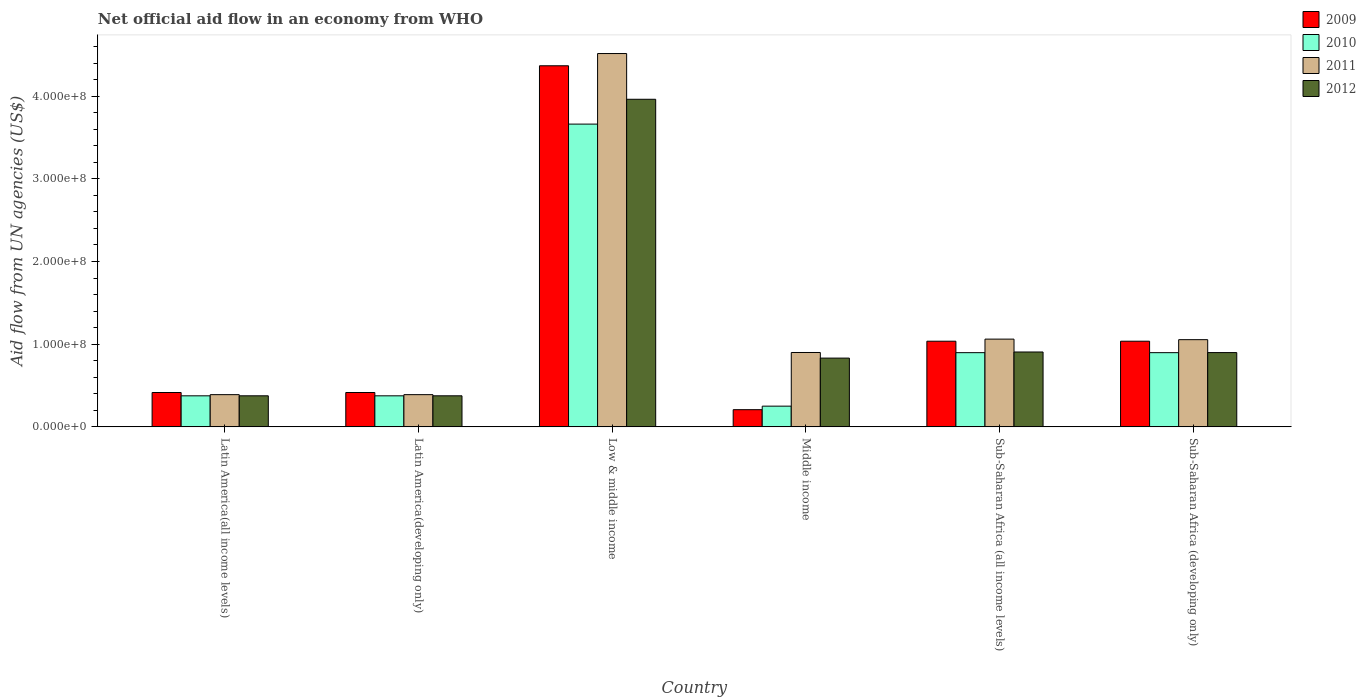How many different coloured bars are there?
Give a very brief answer. 4. How many groups of bars are there?
Ensure brevity in your answer.  6. How many bars are there on the 5th tick from the right?
Ensure brevity in your answer.  4. What is the label of the 2nd group of bars from the left?
Your answer should be compact. Latin America(developing only). What is the net official aid flow in 2009 in Middle income?
Your answer should be very brief. 2.08e+07. Across all countries, what is the maximum net official aid flow in 2009?
Your answer should be very brief. 4.37e+08. Across all countries, what is the minimum net official aid flow in 2009?
Your answer should be very brief. 2.08e+07. In which country was the net official aid flow in 2011 maximum?
Offer a terse response. Low & middle income. In which country was the net official aid flow in 2009 minimum?
Ensure brevity in your answer.  Middle income. What is the total net official aid flow in 2011 in the graph?
Keep it short and to the point. 8.31e+08. What is the difference between the net official aid flow in 2011 in Latin America(developing only) and that in Sub-Saharan Africa (developing only)?
Ensure brevity in your answer.  -6.65e+07. What is the difference between the net official aid flow in 2011 in Middle income and the net official aid flow in 2009 in Sub-Saharan Africa (developing only)?
Make the answer very short. -1.36e+07. What is the average net official aid flow in 2011 per country?
Provide a short and direct response. 1.39e+08. What is the difference between the net official aid flow of/in 2011 and net official aid flow of/in 2010 in Sub-Saharan Africa (developing only)?
Ensure brevity in your answer.  1.57e+07. What is the ratio of the net official aid flow in 2011 in Latin America(all income levels) to that in Middle income?
Offer a terse response. 0.43. Is the difference between the net official aid flow in 2011 in Low & middle income and Middle income greater than the difference between the net official aid flow in 2010 in Low & middle income and Middle income?
Your answer should be compact. Yes. What is the difference between the highest and the second highest net official aid flow in 2011?
Give a very brief answer. 3.46e+08. What is the difference between the highest and the lowest net official aid flow in 2010?
Provide a succinct answer. 3.41e+08. In how many countries, is the net official aid flow in 2010 greater than the average net official aid flow in 2010 taken over all countries?
Ensure brevity in your answer.  1. Is the sum of the net official aid flow in 2009 in Latin America(developing only) and Sub-Saharan Africa (all income levels) greater than the maximum net official aid flow in 2012 across all countries?
Give a very brief answer. No. Is it the case that in every country, the sum of the net official aid flow in 2009 and net official aid flow in 2012 is greater than the sum of net official aid flow in 2011 and net official aid flow in 2010?
Provide a short and direct response. No. What does the 1st bar from the right in Sub-Saharan Africa (developing only) represents?
Keep it short and to the point. 2012. Is it the case that in every country, the sum of the net official aid flow in 2009 and net official aid flow in 2010 is greater than the net official aid flow in 2012?
Offer a very short reply. No. How many bars are there?
Your answer should be compact. 24. What is the difference between two consecutive major ticks on the Y-axis?
Offer a very short reply. 1.00e+08. Does the graph contain grids?
Keep it short and to the point. No. What is the title of the graph?
Give a very brief answer. Net official aid flow in an economy from WHO. What is the label or title of the Y-axis?
Your answer should be compact. Aid flow from UN agencies (US$). What is the Aid flow from UN agencies (US$) of 2009 in Latin America(all income levels)?
Your answer should be very brief. 4.16e+07. What is the Aid flow from UN agencies (US$) of 2010 in Latin America(all income levels)?
Your answer should be very brief. 3.76e+07. What is the Aid flow from UN agencies (US$) in 2011 in Latin America(all income levels)?
Your answer should be compact. 3.90e+07. What is the Aid flow from UN agencies (US$) of 2012 in Latin America(all income levels)?
Provide a short and direct response. 3.76e+07. What is the Aid flow from UN agencies (US$) of 2009 in Latin America(developing only)?
Offer a terse response. 4.16e+07. What is the Aid flow from UN agencies (US$) in 2010 in Latin America(developing only)?
Provide a short and direct response. 3.76e+07. What is the Aid flow from UN agencies (US$) of 2011 in Latin America(developing only)?
Provide a succinct answer. 3.90e+07. What is the Aid flow from UN agencies (US$) of 2012 in Latin America(developing only)?
Your response must be concise. 3.76e+07. What is the Aid flow from UN agencies (US$) in 2009 in Low & middle income?
Your answer should be very brief. 4.37e+08. What is the Aid flow from UN agencies (US$) of 2010 in Low & middle income?
Your answer should be compact. 3.66e+08. What is the Aid flow from UN agencies (US$) of 2011 in Low & middle income?
Provide a short and direct response. 4.52e+08. What is the Aid flow from UN agencies (US$) of 2012 in Low & middle income?
Ensure brevity in your answer.  3.96e+08. What is the Aid flow from UN agencies (US$) in 2009 in Middle income?
Keep it short and to the point. 2.08e+07. What is the Aid flow from UN agencies (US$) of 2010 in Middle income?
Your response must be concise. 2.51e+07. What is the Aid flow from UN agencies (US$) in 2011 in Middle income?
Provide a short and direct response. 9.00e+07. What is the Aid flow from UN agencies (US$) of 2012 in Middle income?
Provide a succinct answer. 8.32e+07. What is the Aid flow from UN agencies (US$) of 2009 in Sub-Saharan Africa (all income levels)?
Keep it short and to the point. 1.04e+08. What is the Aid flow from UN agencies (US$) of 2010 in Sub-Saharan Africa (all income levels)?
Offer a very short reply. 8.98e+07. What is the Aid flow from UN agencies (US$) of 2011 in Sub-Saharan Africa (all income levels)?
Offer a very short reply. 1.06e+08. What is the Aid flow from UN agencies (US$) of 2012 in Sub-Saharan Africa (all income levels)?
Keep it short and to the point. 9.06e+07. What is the Aid flow from UN agencies (US$) of 2009 in Sub-Saharan Africa (developing only)?
Provide a short and direct response. 1.04e+08. What is the Aid flow from UN agencies (US$) of 2010 in Sub-Saharan Africa (developing only)?
Your answer should be very brief. 8.98e+07. What is the Aid flow from UN agencies (US$) in 2011 in Sub-Saharan Africa (developing only)?
Your answer should be very brief. 1.05e+08. What is the Aid flow from UN agencies (US$) in 2012 in Sub-Saharan Africa (developing only)?
Your answer should be compact. 8.98e+07. Across all countries, what is the maximum Aid flow from UN agencies (US$) in 2009?
Provide a succinct answer. 4.37e+08. Across all countries, what is the maximum Aid flow from UN agencies (US$) in 2010?
Offer a very short reply. 3.66e+08. Across all countries, what is the maximum Aid flow from UN agencies (US$) of 2011?
Keep it short and to the point. 4.52e+08. Across all countries, what is the maximum Aid flow from UN agencies (US$) in 2012?
Your answer should be very brief. 3.96e+08. Across all countries, what is the minimum Aid flow from UN agencies (US$) of 2009?
Give a very brief answer. 2.08e+07. Across all countries, what is the minimum Aid flow from UN agencies (US$) in 2010?
Give a very brief answer. 2.51e+07. Across all countries, what is the minimum Aid flow from UN agencies (US$) of 2011?
Make the answer very short. 3.90e+07. Across all countries, what is the minimum Aid flow from UN agencies (US$) in 2012?
Offer a very short reply. 3.76e+07. What is the total Aid flow from UN agencies (US$) in 2009 in the graph?
Give a very brief answer. 7.48e+08. What is the total Aid flow from UN agencies (US$) of 2010 in the graph?
Provide a short and direct response. 6.46e+08. What is the total Aid flow from UN agencies (US$) of 2011 in the graph?
Offer a very short reply. 8.31e+08. What is the total Aid flow from UN agencies (US$) of 2012 in the graph?
Provide a short and direct response. 7.35e+08. What is the difference between the Aid flow from UN agencies (US$) of 2009 in Latin America(all income levels) and that in Latin America(developing only)?
Make the answer very short. 0. What is the difference between the Aid flow from UN agencies (US$) in 2012 in Latin America(all income levels) and that in Latin America(developing only)?
Keep it short and to the point. 0. What is the difference between the Aid flow from UN agencies (US$) of 2009 in Latin America(all income levels) and that in Low & middle income?
Provide a short and direct response. -3.95e+08. What is the difference between the Aid flow from UN agencies (US$) in 2010 in Latin America(all income levels) and that in Low & middle income?
Make the answer very short. -3.29e+08. What is the difference between the Aid flow from UN agencies (US$) of 2011 in Latin America(all income levels) and that in Low & middle income?
Offer a terse response. -4.13e+08. What is the difference between the Aid flow from UN agencies (US$) in 2012 in Latin America(all income levels) and that in Low & middle income?
Your answer should be compact. -3.59e+08. What is the difference between the Aid flow from UN agencies (US$) in 2009 in Latin America(all income levels) and that in Middle income?
Provide a short and direct response. 2.08e+07. What is the difference between the Aid flow from UN agencies (US$) of 2010 in Latin America(all income levels) and that in Middle income?
Your answer should be very brief. 1.25e+07. What is the difference between the Aid flow from UN agencies (US$) of 2011 in Latin America(all income levels) and that in Middle income?
Provide a short and direct response. -5.10e+07. What is the difference between the Aid flow from UN agencies (US$) in 2012 in Latin America(all income levels) and that in Middle income?
Your response must be concise. -4.56e+07. What is the difference between the Aid flow from UN agencies (US$) of 2009 in Latin America(all income levels) and that in Sub-Saharan Africa (all income levels)?
Provide a succinct answer. -6.20e+07. What is the difference between the Aid flow from UN agencies (US$) in 2010 in Latin America(all income levels) and that in Sub-Saharan Africa (all income levels)?
Provide a succinct answer. -5.22e+07. What is the difference between the Aid flow from UN agencies (US$) of 2011 in Latin America(all income levels) and that in Sub-Saharan Africa (all income levels)?
Provide a succinct answer. -6.72e+07. What is the difference between the Aid flow from UN agencies (US$) of 2012 in Latin America(all income levels) and that in Sub-Saharan Africa (all income levels)?
Keep it short and to the point. -5.30e+07. What is the difference between the Aid flow from UN agencies (US$) of 2009 in Latin America(all income levels) and that in Sub-Saharan Africa (developing only)?
Ensure brevity in your answer.  -6.20e+07. What is the difference between the Aid flow from UN agencies (US$) of 2010 in Latin America(all income levels) and that in Sub-Saharan Africa (developing only)?
Provide a succinct answer. -5.22e+07. What is the difference between the Aid flow from UN agencies (US$) of 2011 in Latin America(all income levels) and that in Sub-Saharan Africa (developing only)?
Give a very brief answer. -6.65e+07. What is the difference between the Aid flow from UN agencies (US$) of 2012 in Latin America(all income levels) and that in Sub-Saharan Africa (developing only)?
Offer a terse response. -5.23e+07. What is the difference between the Aid flow from UN agencies (US$) in 2009 in Latin America(developing only) and that in Low & middle income?
Provide a succinct answer. -3.95e+08. What is the difference between the Aid flow from UN agencies (US$) of 2010 in Latin America(developing only) and that in Low & middle income?
Offer a very short reply. -3.29e+08. What is the difference between the Aid flow from UN agencies (US$) in 2011 in Latin America(developing only) and that in Low & middle income?
Make the answer very short. -4.13e+08. What is the difference between the Aid flow from UN agencies (US$) in 2012 in Latin America(developing only) and that in Low & middle income?
Your answer should be compact. -3.59e+08. What is the difference between the Aid flow from UN agencies (US$) in 2009 in Latin America(developing only) and that in Middle income?
Offer a terse response. 2.08e+07. What is the difference between the Aid flow from UN agencies (US$) of 2010 in Latin America(developing only) and that in Middle income?
Your answer should be compact. 1.25e+07. What is the difference between the Aid flow from UN agencies (US$) in 2011 in Latin America(developing only) and that in Middle income?
Offer a very short reply. -5.10e+07. What is the difference between the Aid flow from UN agencies (US$) in 2012 in Latin America(developing only) and that in Middle income?
Make the answer very short. -4.56e+07. What is the difference between the Aid flow from UN agencies (US$) of 2009 in Latin America(developing only) and that in Sub-Saharan Africa (all income levels)?
Make the answer very short. -6.20e+07. What is the difference between the Aid flow from UN agencies (US$) of 2010 in Latin America(developing only) and that in Sub-Saharan Africa (all income levels)?
Offer a terse response. -5.22e+07. What is the difference between the Aid flow from UN agencies (US$) in 2011 in Latin America(developing only) and that in Sub-Saharan Africa (all income levels)?
Make the answer very short. -6.72e+07. What is the difference between the Aid flow from UN agencies (US$) in 2012 in Latin America(developing only) and that in Sub-Saharan Africa (all income levels)?
Keep it short and to the point. -5.30e+07. What is the difference between the Aid flow from UN agencies (US$) of 2009 in Latin America(developing only) and that in Sub-Saharan Africa (developing only)?
Your answer should be compact. -6.20e+07. What is the difference between the Aid flow from UN agencies (US$) of 2010 in Latin America(developing only) and that in Sub-Saharan Africa (developing only)?
Give a very brief answer. -5.22e+07. What is the difference between the Aid flow from UN agencies (US$) of 2011 in Latin America(developing only) and that in Sub-Saharan Africa (developing only)?
Provide a short and direct response. -6.65e+07. What is the difference between the Aid flow from UN agencies (US$) of 2012 in Latin America(developing only) and that in Sub-Saharan Africa (developing only)?
Your answer should be very brief. -5.23e+07. What is the difference between the Aid flow from UN agencies (US$) of 2009 in Low & middle income and that in Middle income?
Provide a short and direct response. 4.16e+08. What is the difference between the Aid flow from UN agencies (US$) in 2010 in Low & middle income and that in Middle income?
Your answer should be very brief. 3.41e+08. What is the difference between the Aid flow from UN agencies (US$) of 2011 in Low & middle income and that in Middle income?
Offer a terse response. 3.62e+08. What is the difference between the Aid flow from UN agencies (US$) of 2012 in Low & middle income and that in Middle income?
Your answer should be very brief. 3.13e+08. What is the difference between the Aid flow from UN agencies (US$) in 2009 in Low & middle income and that in Sub-Saharan Africa (all income levels)?
Provide a succinct answer. 3.33e+08. What is the difference between the Aid flow from UN agencies (US$) of 2010 in Low & middle income and that in Sub-Saharan Africa (all income levels)?
Provide a succinct answer. 2.76e+08. What is the difference between the Aid flow from UN agencies (US$) of 2011 in Low & middle income and that in Sub-Saharan Africa (all income levels)?
Provide a succinct answer. 3.45e+08. What is the difference between the Aid flow from UN agencies (US$) of 2012 in Low & middle income and that in Sub-Saharan Africa (all income levels)?
Give a very brief answer. 3.06e+08. What is the difference between the Aid flow from UN agencies (US$) in 2009 in Low & middle income and that in Sub-Saharan Africa (developing only)?
Make the answer very short. 3.33e+08. What is the difference between the Aid flow from UN agencies (US$) in 2010 in Low & middle income and that in Sub-Saharan Africa (developing only)?
Your response must be concise. 2.76e+08. What is the difference between the Aid flow from UN agencies (US$) of 2011 in Low & middle income and that in Sub-Saharan Africa (developing only)?
Give a very brief answer. 3.46e+08. What is the difference between the Aid flow from UN agencies (US$) in 2012 in Low & middle income and that in Sub-Saharan Africa (developing only)?
Offer a terse response. 3.06e+08. What is the difference between the Aid flow from UN agencies (US$) in 2009 in Middle income and that in Sub-Saharan Africa (all income levels)?
Your answer should be compact. -8.28e+07. What is the difference between the Aid flow from UN agencies (US$) in 2010 in Middle income and that in Sub-Saharan Africa (all income levels)?
Make the answer very short. -6.47e+07. What is the difference between the Aid flow from UN agencies (US$) of 2011 in Middle income and that in Sub-Saharan Africa (all income levels)?
Ensure brevity in your answer.  -1.62e+07. What is the difference between the Aid flow from UN agencies (US$) of 2012 in Middle income and that in Sub-Saharan Africa (all income levels)?
Your response must be concise. -7.39e+06. What is the difference between the Aid flow from UN agencies (US$) of 2009 in Middle income and that in Sub-Saharan Africa (developing only)?
Provide a short and direct response. -8.28e+07. What is the difference between the Aid flow from UN agencies (US$) of 2010 in Middle income and that in Sub-Saharan Africa (developing only)?
Your response must be concise. -6.47e+07. What is the difference between the Aid flow from UN agencies (US$) in 2011 in Middle income and that in Sub-Saharan Africa (developing only)?
Offer a very short reply. -1.55e+07. What is the difference between the Aid flow from UN agencies (US$) in 2012 in Middle income and that in Sub-Saharan Africa (developing only)?
Offer a terse response. -6.67e+06. What is the difference between the Aid flow from UN agencies (US$) in 2009 in Sub-Saharan Africa (all income levels) and that in Sub-Saharan Africa (developing only)?
Your answer should be compact. 0. What is the difference between the Aid flow from UN agencies (US$) in 2010 in Sub-Saharan Africa (all income levels) and that in Sub-Saharan Africa (developing only)?
Offer a terse response. 0. What is the difference between the Aid flow from UN agencies (US$) of 2011 in Sub-Saharan Africa (all income levels) and that in Sub-Saharan Africa (developing only)?
Provide a short and direct response. 6.70e+05. What is the difference between the Aid flow from UN agencies (US$) of 2012 in Sub-Saharan Africa (all income levels) and that in Sub-Saharan Africa (developing only)?
Your response must be concise. 7.20e+05. What is the difference between the Aid flow from UN agencies (US$) in 2009 in Latin America(all income levels) and the Aid flow from UN agencies (US$) in 2010 in Latin America(developing only)?
Your answer should be compact. 4.01e+06. What is the difference between the Aid flow from UN agencies (US$) of 2009 in Latin America(all income levels) and the Aid flow from UN agencies (US$) of 2011 in Latin America(developing only)?
Give a very brief answer. 2.59e+06. What is the difference between the Aid flow from UN agencies (US$) in 2009 in Latin America(all income levels) and the Aid flow from UN agencies (US$) in 2012 in Latin America(developing only)?
Your answer should be very brief. 3.99e+06. What is the difference between the Aid flow from UN agencies (US$) of 2010 in Latin America(all income levels) and the Aid flow from UN agencies (US$) of 2011 in Latin America(developing only)?
Give a very brief answer. -1.42e+06. What is the difference between the Aid flow from UN agencies (US$) of 2010 in Latin America(all income levels) and the Aid flow from UN agencies (US$) of 2012 in Latin America(developing only)?
Give a very brief answer. -2.00e+04. What is the difference between the Aid flow from UN agencies (US$) in 2011 in Latin America(all income levels) and the Aid flow from UN agencies (US$) in 2012 in Latin America(developing only)?
Provide a succinct answer. 1.40e+06. What is the difference between the Aid flow from UN agencies (US$) of 2009 in Latin America(all income levels) and the Aid flow from UN agencies (US$) of 2010 in Low & middle income?
Offer a very short reply. -3.25e+08. What is the difference between the Aid flow from UN agencies (US$) of 2009 in Latin America(all income levels) and the Aid flow from UN agencies (US$) of 2011 in Low & middle income?
Your answer should be compact. -4.10e+08. What is the difference between the Aid flow from UN agencies (US$) of 2009 in Latin America(all income levels) and the Aid flow from UN agencies (US$) of 2012 in Low & middle income?
Your response must be concise. -3.55e+08. What is the difference between the Aid flow from UN agencies (US$) of 2010 in Latin America(all income levels) and the Aid flow from UN agencies (US$) of 2011 in Low & middle income?
Provide a short and direct response. -4.14e+08. What is the difference between the Aid flow from UN agencies (US$) in 2010 in Latin America(all income levels) and the Aid flow from UN agencies (US$) in 2012 in Low & middle income?
Your answer should be very brief. -3.59e+08. What is the difference between the Aid flow from UN agencies (US$) in 2011 in Latin America(all income levels) and the Aid flow from UN agencies (US$) in 2012 in Low & middle income?
Offer a very short reply. -3.57e+08. What is the difference between the Aid flow from UN agencies (US$) of 2009 in Latin America(all income levels) and the Aid flow from UN agencies (US$) of 2010 in Middle income?
Offer a terse response. 1.65e+07. What is the difference between the Aid flow from UN agencies (US$) in 2009 in Latin America(all income levels) and the Aid flow from UN agencies (US$) in 2011 in Middle income?
Keep it short and to the point. -4.84e+07. What is the difference between the Aid flow from UN agencies (US$) of 2009 in Latin America(all income levels) and the Aid flow from UN agencies (US$) of 2012 in Middle income?
Your answer should be compact. -4.16e+07. What is the difference between the Aid flow from UN agencies (US$) of 2010 in Latin America(all income levels) and the Aid flow from UN agencies (US$) of 2011 in Middle income?
Keep it short and to the point. -5.24e+07. What is the difference between the Aid flow from UN agencies (US$) in 2010 in Latin America(all income levels) and the Aid flow from UN agencies (US$) in 2012 in Middle income?
Offer a terse response. -4.56e+07. What is the difference between the Aid flow from UN agencies (US$) of 2011 in Latin America(all income levels) and the Aid flow from UN agencies (US$) of 2012 in Middle income?
Offer a very short reply. -4.42e+07. What is the difference between the Aid flow from UN agencies (US$) of 2009 in Latin America(all income levels) and the Aid flow from UN agencies (US$) of 2010 in Sub-Saharan Africa (all income levels)?
Your answer should be very brief. -4.82e+07. What is the difference between the Aid flow from UN agencies (US$) of 2009 in Latin America(all income levels) and the Aid flow from UN agencies (US$) of 2011 in Sub-Saharan Africa (all income levels)?
Your answer should be compact. -6.46e+07. What is the difference between the Aid flow from UN agencies (US$) in 2009 in Latin America(all income levels) and the Aid flow from UN agencies (US$) in 2012 in Sub-Saharan Africa (all income levels)?
Offer a terse response. -4.90e+07. What is the difference between the Aid flow from UN agencies (US$) in 2010 in Latin America(all income levels) and the Aid flow from UN agencies (US$) in 2011 in Sub-Saharan Africa (all income levels)?
Provide a succinct answer. -6.86e+07. What is the difference between the Aid flow from UN agencies (US$) in 2010 in Latin America(all income levels) and the Aid flow from UN agencies (US$) in 2012 in Sub-Saharan Africa (all income levels)?
Your answer should be compact. -5.30e+07. What is the difference between the Aid flow from UN agencies (US$) in 2011 in Latin America(all income levels) and the Aid flow from UN agencies (US$) in 2012 in Sub-Saharan Africa (all income levels)?
Offer a very short reply. -5.16e+07. What is the difference between the Aid flow from UN agencies (US$) in 2009 in Latin America(all income levels) and the Aid flow from UN agencies (US$) in 2010 in Sub-Saharan Africa (developing only)?
Keep it short and to the point. -4.82e+07. What is the difference between the Aid flow from UN agencies (US$) in 2009 in Latin America(all income levels) and the Aid flow from UN agencies (US$) in 2011 in Sub-Saharan Africa (developing only)?
Your response must be concise. -6.39e+07. What is the difference between the Aid flow from UN agencies (US$) in 2009 in Latin America(all income levels) and the Aid flow from UN agencies (US$) in 2012 in Sub-Saharan Africa (developing only)?
Keep it short and to the point. -4.83e+07. What is the difference between the Aid flow from UN agencies (US$) in 2010 in Latin America(all income levels) and the Aid flow from UN agencies (US$) in 2011 in Sub-Saharan Africa (developing only)?
Offer a terse response. -6.79e+07. What is the difference between the Aid flow from UN agencies (US$) in 2010 in Latin America(all income levels) and the Aid flow from UN agencies (US$) in 2012 in Sub-Saharan Africa (developing only)?
Offer a very short reply. -5.23e+07. What is the difference between the Aid flow from UN agencies (US$) in 2011 in Latin America(all income levels) and the Aid flow from UN agencies (US$) in 2012 in Sub-Saharan Africa (developing only)?
Give a very brief answer. -5.09e+07. What is the difference between the Aid flow from UN agencies (US$) of 2009 in Latin America(developing only) and the Aid flow from UN agencies (US$) of 2010 in Low & middle income?
Offer a terse response. -3.25e+08. What is the difference between the Aid flow from UN agencies (US$) in 2009 in Latin America(developing only) and the Aid flow from UN agencies (US$) in 2011 in Low & middle income?
Give a very brief answer. -4.10e+08. What is the difference between the Aid flow from UN agencies (US$) of 2009 in Latin America(developing only) and the Aid flow from UN agencies (US$) of 2012 in Low & middle income?
Your answer should be compact. -3.55e+08. What is the difference between the Aid flow from UN agencies (US$) in 2010 in Latin America(developing only) and the Aid flow from UN agencies (US$) in 2011 in Low & middle income?
Provide a short and direct response. -4.14e+08. What is the difference between the Aid flow from UN agencies (US$) in 2010 in Latin America(developing only) and the Aid flow from UN agencies (US$) in 2012 in Low & middle income?
Make the answer very short. -3.59e+08. What is the difference between the Aid flow from UN agencies (US$) of 2011 in Latin America(developing only) and the Aid flow from UN agencies (US$) of 2012 in Low & middle income?
Your answer should be very brief. -3.57e+08. What is the difference between the Aid flow from UN agencies (US$) in 2009 in Latin America(developing only) and the Aid flow from UN agencies (US$) in 2010 in Middle income?
Give a very brief answer. 1.65e+07. What is the difference between the Aid flow from UN agencies (US$) of 2009 in Latin America(developing only) and the Aid flow from UN agencies (US$) of 2011 in Middle income?
Your answer should be compact. -4.84e+07. What is the difference between the Aid flow from UN agencies (US$) in 2009 in Latin America(developing only) and the Aid flow from UN agencies (US$) in 2012 in Middle income?
Make the answer very short. -4.16e+07. What is the difference between the Aid flow from UN agencies (US$) in 2010 in Latin America(developing only) and the Aid flow from UN agencies (US$) in 2011 in Middle income?
Offer a terse response. -5.24e+07. What is the difference between the Aid flow from UN agencies (US$) in 2010 in Latin America(developing only) and the Aid flow from UN agencies (US$) in 2012 in Middle income?
Keep it short and to the point. -4.56e+07. What is the difference between the Aid flow from UN agencies (US$) of 2011 in Latin America(developing only) and the Aid flow from UN agencies (US$) of 2012 in Middle income?
Provide a succinct answer. -4.42e+07. What is the difference between the Aid flow from UN agencies (US$) of 2009 in Latin America(developing only) and the Aid flow from UN agencies (US$) of 2010 in Sub-Saharan Africa (all income levels)?
Ensure brevity in your answer.  -4.82e+07. What is the difference between the Aid flow from UN agencies (US$) of 2009 in Latin America(developing only) and the Aid flow from UN agencies (US$) of 2011 in Sub-Saharan Africa (all income levels)?
Your answer should be very brief. -6.46e+07. What is the difference between the Aid flow from UN agencies (US$) in 2009 in Latin America(developing only) and the Aid flow from UN agencies (US$) in 2012 in Sub-Saharan Africa (all income levels)?
Your response must be concise. -4.90e+07. What is the difference between the Aid flow from UN agencies (US$) of 2010 in Latin America(developing only) and the Aid flow from UN agencies (US$) of 2011 in Sub-Saharan Africa (all income levels)?
Ensure brevity in your answer.  -6.86e+07. What is the difference between the Aid flow from UN agencies (US$) of 2010 in Latin America(developing only) and the Aid flow from UN agencies (US$) of 2012 in Sub-Saharan Africa (all income levels)?
Give a very brief answer. -5.30e+07. What is the difference between the Aid flow from UN agencies (US$) of 2011 in Latin America(developing only) and the Aid flow from UN agencies (US$) of 2012 in Sub-Saharan Africa (all income levels)?
Offer a terse response. -5.16e+07. What is the difference between the Aid flow from UN agencies (US$) of 2009 in Latin America(developing only) and the Aid flow from UN agencies (US$) of 2010 in Sub-Saharan Africa (developing only)?
Make the answer very short. -4.82e+07. What is the difference between the Aid flow from UN agencies (US$) of 2009 in Latin America(developing only) and the Aid flow from UN agencies (US$) of 2011 in Sub-Saharan Africa (developing only)?
Your response must be concise. -6.39e+07. What is the difference between the Aid flow from UN agencies (US$) of 2009 in Latin America(developing only) and the Aid flow from UN agencies (US$) of 2012 in Sub-Saharan Africa (developing only)?
Your response must be concise. -4.83e+07. What is the difference between the Aid flow from UN agencies (US$) in 2010 in Latin America(developing only) and the Aid flow from UN agencies (US$) in 2011 in Sub-Saharan Africa (developing only)?
Ensure brevity in your answer.  -6.79e+07. What is the difference between the Aid flow from UN agencies (US$) in 2010 in Latin America(developing only) and the Aid flow from UN agencies (US$) in 2012 in Sub-Saharan Africa (developing only)?
Make the answer very short. -5.23e+07. What is the difference between the Aid flow from UN agencies (US$) in 2011 in Latin America(developing only) and the Aid flow from UN agencies (US$) in 2012 in Sub-Saharan Africa (developing only)?
Offer a very short reply. -5.09e+07. What is the difference between the Aid flow from UN agencies (US$) in 2009 in Low & middle income and the Aid flow from UN agencies (US$) in 2010 in Middle income?
Your response must be concise. 4.12e+08. What is the difference between the Aid flow from UN agencies (US$) of 2009 in Low & middle income and the Aid flow from UN agencies (US$) of 2011 in Middle income?
Offer a very short reply. 3.47e+08. What is the difference between the Aid flow from UN agencies (US$) in 2009 in Low & middle income and the Aid flow from UN agencies (US$) in 2012 in Middle income?
Offer a very short reply. 3.54e+08. What is the difference between the Aid flow from UN agencies (US$) in 2010 in Low & middle income and the Aid flow from UN agencies (US$) in 2011 in Middle income?
Your response must be concise. 2.76e+08. What is the difference between the Aid flow from UN agencies (US$) of 2010 in Low & middle income and the Aid flow from UN agencies (US$) of 2012 in Middle income?
Offer a terse response. 2.83e+08. What is the difference between the Aid flow from UN agencies (US$) of 2011 in Low & middle income and the Aid flow from UN agencies (US$) of 2012 in Middle income?
Offer a terse response. 3.68e+08. What is the difference between the Aid flow from UN agencies (US$) in 2009 in Low & middle income and the Aid flow from UN agencies (US$) in 2010 in Sub-Saharan Africa (all income levels)?
Provide a succinct answer. 3.47e+08. What is the difference between the Aid flow from UN agencies (US$) in 2009 in Low & middle income and the Aid flow from UN agencies (US$) in 2011 in Sub-Saharan Africa (all income levels)?
Your response must be concise. 3.31e+08. What is the difference between the Aid flow from UN agencies (US$) in 2009 in Low & middle income and the Aid flow from UN agencies (US$) in 2012 in Sub-Saharan Africa (all income levels)?
Offer a terse response. 3.46e+08. What is the difference between the Aid flow from UN agencies (US$) in 2010 in Low & middle income and the Aid flow from UN agencies (US$) in 2011 in Sub-Saharan Africa (all income levels)?
Your response must be concise. 2.60e+08. What is the difference between the Aid flow from UN agencies (US$) of 2010 in Low & middle income and the Aid flow from UN agencies (US$) of 2012 in Sub-Saharan Africa (all income levels)?
Offer a terse response. 2.76e+08. What is the difference between the Aid flow from UN agencies (US$) in 2011 in Low & middle income and the Aid flow from UN agencies (US$) in 2012 in Sub-Saharan Africa (all income levels)?
Provide a short and direct response. 3.61e+08. What is the difference between the Aid flow from UN agencies (US$) in 2009 in Low & middle income and the Aid flow from UN agencies (US$) in 2010 in Sub-Saharan Africa (developing only)?
Provide a short and direct response. 3.47e+08. What is the difference between the Aid flow from UN agencies (US$) of 2009 in Low & middle income and the Aid flow from UN agencies (US$) of 2011 in Sub-Saharan Africa (developing only)?
Your response must be concise. 3.31e+08. What is the difference between the Aid flow from UN agencies (US$) of 2009 in Low & middle income and the Aid flow from UN agencies (US$) of 2012 in Sub-Saharan Africa (developing only)?
Your response must be concise. 3.47e+08. What is the difference between the Aid flow from UN agencies (US$) in 2010 in Low & middle income and the Aid flow from UN agencies (US$) in 2011 in Sub-Saharan Africa (developing only)?
Make the answer very short. 2.61e+08. What is the difference between the Aid flow from UN agencies (US$) of 2010 in Low & middle income and the Aid flow from UN agencies (US$) of 2012 in Sub-Saharan Africa (developing only)?
Offer a very short reply. 2.76e+08. What is the difference between the Aid flow from UN agencies (US$) of 2011 in Low & middle income and the Aid flow from UN agencies (US$) of 2012 in Sub-Saharan Africa (developing only)?
Give a very brief answer. 3.62e+08. What is the difference between the Aid flow from UN agencies (US$) of 2009 in Middle income and the Aid flow from UN agencies (US$) of 2010 in Sub-Saharan Africa (all income levels)?
Make the answer very short. -6.90e+07. What is the difference between the Aid flow from UN agencies (US$) of 2009 in Middle income and the Aid flow from UN agencies (US$) of 2011 in Sub-Saharan Africa (all income levels)?
Your answer should be very brief. -8.54e+07. What is the difference between the Aid flow from UN agencies (US$) in 2009 in Middle income and the Aid flow from UN agencies (US$) in 2012 in Sub-Saharan Africa (all income levels)?
Your answer should be compact. -6.98e+07. What is the difference between the Aid flow from UN agencies (US$) of 2010 in Middle income and the Aid flow from UN agencies (US$) of 2011 in Sub-Saharan Africa (all income levels)?
Offer a very short reply. -8.11e+07. What is the difference between the Aid flow from UN agencies (US$) in 2010 in Middle income and the Aid flow from UN agencies (US$) in 2012 in Sub-Saharan Africa (all income levels)?
Provide a short and direct response. -6.55e+07. What is the difference between the Aid flow from UN agencies (US$) of 2011 in Middle income and the Aid flow from UN agencies (US$) of 2012 in Sub-Saharan Africa (all income levels)?
Offer a terse response. -5.90e+05. What is the difference between the Aid flow from UN agencies (US$) in 2009 in Middle income and the Aid flow from UN agencies (US$) in 2010 in Sub-Saharan Africa (developing only)?
Give a very brief answer. -6.90e+07. What is the difference between the Aid flow from UN agencies (US$) in 2009 in Middle income and the Aid flow from UN agencies (US$) in 2011 in Sub-Saharan Africa (developing only)?
Offer a very short reply. -8.47e+07. What is the difference between the Aid flow from UN agencies (US$) in 2009 in Middle income and the Aid flow from UN agencies (US$) in 2012 in Sub-Saharan Africa (developing only)?
Your answer should be compact. -6.90e+07. What is the difference between the Aid flow from UN agencies (US$) in 2010 in Middle income and the Aid flow from UN agencies (US$) in 2011 in Sub-Saharan Africa (developing only)?
Make the answer very short. -8.04e+07. What is the difference between the Aid flow from UN agencies (US$) in 2010 in Middle income and the Aid flow from UN agencies (US$) in 2012 in Sub-Saharan Africa (developing only)?
Offer a very short reply. -6.48e+07. What is the difference between the Aid flow from UN agencies (US$) of 2009 in Sub-Saharan Africa (all income levels) and the Aid flow from UN agencies (US$) of 2010 in Sub-Saharan Africa (developing only)?
Keep it short and to the point. 1.39e+07. What is the difference between the Aid flow from UN agencies (US$) in 2009 in Sub-Saharan Africa (all income levels) and the Aid flow from UN agencies (US$) in 2011 in Sub-Saharan Africa (developing only)?
Give a very brief answer. -1.86e+06. What is the difference between the Aid flow from UN agencies (US$) of 2009 in Sub-Saharan Africa (all income levels) and the Aid flow from UN agencies (US$) of 2012 in Sub-Saharan Africa (developing only)?
Make the answer very short. 1.38e+07. What is the difference between the Aid flow from UN agencies (US$) of 2010 in Sub-Saharan Africa (all income levels) and the Aid flow from UN agencies (US$) of 2011 in Sub-Saharan Africa (developing only)?
Your answer should be very brief. -1.57e+07. What is the difference between the Aid flow from UN agencies (US$) in 2011 in Sub-Saharan Africa (all income levels) and the Aid flow from UN agencies (US$) in 2012 in Sub-Saharan Africa (developing only)?
Ensure brevity in your answer.  1.63e+07. What is the average Aid flow from UN agencies (US$) in 2009 per country?
Offer a terse response. 1.25e+08. What is the average Aid flow from UN agencies (US$) of 2010 per country?
Your response must be concise. 1.08e+08. What is the average Aid flow from UN agencies (US$) in 2011 per country?
Give a very brief answer. 1.39e+08. What is the average Aid flow from UN agencies (US$) in 2012 per country?
Your answer should be very brief. 1.23e+08. What is the difference between the Aid flow from UN agencies (US$) of 2009 and Aid flow from UN agencies (US$) of 2010 in Latin America(all income levels)?
Give a very brief answer. 4.01e+06. What is the difference between the Aid flow from UN agencies (US$) in 2009 and Aid flow from UN agencies (US$) in 2011 in Latin America(all income levels)?
Keep it short and to the point. 2.59e+06. What is the difference between the Aid flow from UN agencies (US$) in 2009 and Aid flow from UN agencies (US$) in 2012 in Latin America(all income levels)?
Your response must be concise. 3.99e+06. What is the difference between the Aid flow from UN agencies (US$) of 2010 and Aid flow from UN agencies (US$) of 2011 in Latin America(all income levels)?
Your response must be concise. -1.42e+06. What is the difference between the Aid flow from UN agencies (US$) of 2010 and Aid flow from UN agencies (US$) of 2012 in Latin America(all income levels)?
Your response must be concise. -2.00e+04. What is the difference between the Aid flow from UN agencies (US$) of 2011 and Aid flow from UN agencies (US$) of 2012 in Latin America(all income levels)?
Your answer should be very brief. 1.40e+06. What is the difference between the Aid flow from UN agencies (US$) in 2009 and Aid flow from UN agencies (US$) in 2010 in Latin America(developing only)?
Keep it short and to the point. 4.01e+06. What is the difference between the Aid flow from UN agencies (US$) of 2009 and Aid flow from UN agencies (US$) of 2011 in Latin America(developing only)?
Keep it short and to the point. 2.59e+06. What is the difference between the Aid flow from UN agencies (US$) of 2009 and Aid flow from UN agencies (US$) of 2012 in Latin America(developing only)?
Provide a succinct answer. 3.99e+06. What is the difference between the Aid flow from UN agencies (US$) of 2010 and Aid flow from UN agencies (US$) of 2011 in Latin America(developing only)?
Your answer should be very brief. -1.42e+06. What is the difference between the Aid flow from UN agencies (US$) of 2011 and Aid flow from UN agencies (US$) of 2012 in Latin America(developing only)?
Provide a succinct answer. 1.40e+06. What is the difference between the Aid flow from UN agencies (US$) of 2009 and Aid flow from UN agencies (US$) of 2010 in Low & middle income?
Ensure brevity in your answer.  7.06e+07. What is the difference between the Aid flow from UN agencies (US$) of 2009 and Aid flow from UN agencies (US$) of 2011 in Low & middle income?
Make the answer very short. -1.48e+07. What is the difference between the Aid flow from UN agencies (US$) of 2009 and Aid flow from UN agencies (US$) of 2012 in Low & middle income?
Ensure brevity in your answer.  4.05e+07. What is the difference between the Aid flow from UN agencies (US$) of 2010 and Aid flow from UN agencies (US$) of 2011 in Low & middle income?
Offer a very short reply. -8.54e+07. What is the difference between the Aid flow from UN agencies (US$) in 2010 and Aid flow from UN agencies (US$) in 2012 in Low & middle income?
Provide a succinct answer. -3.00e+07. What is the difference between the Aid flow from UN agencies (US$) of 2011 and Aid flow from UN agencies (US$) of 2012 in Low & middle income?
Your response must be concise. 5.53e+07. What is the difference between the Aid flow from UN agencies (US$) of 2009 and Aid flow from UN agencies (US$) of 2010 in Middle income?
Your response must be concise. -4.27e+06. What is the difference between the Aid flow from UN agencies (US$) of 2009 and Aid flow from UN agencies (US$) of 2011 in Middle income?
Keep it short and to the point. -6.92e+07. What is the difference between the Aid flow from UN agencies (US$) of 2009 and Aid flow from UN agencies (US$) of 2012 in Middle income?
Your response must be concise. -6.24e+07. What is the difference between the Aid flow from UN agencies (US$) of 2010 and Aid flow from UN agencies (US$) of 2011 in Middle income?
Make the answer very short. -6.49e+07. What is the difference between the Aid flow from UN agencies (US$) in 2010 and Aid flow from UN agencies (US$) in 2012 in Middle income?
Your answer should be very brief. -5.81e+07. What is the difference between the Aid flow from UN agencies (US$) of 2011 and Aid flow from UN agencies (US$) of 2012 in Middle income?
Ensure brevity in your answer.  6.80e+06. What is the difference between the Aid flow from UN agencies (US$) in 2009 and Aid flow from UN agencies (US$) in 2010 in Sub-Saharan Africa (all income levels)?
Ensure brevity in your answer.  1.39e+07. What is the difference between the Aid flow from UN agencies (US$) of 2009 and Aid flow from UN agencies (US$) of 2011 in Sub-Saharan Africa (all income levels)?
Provide a short and direct response. -2.53e+06. What is the difference between the Aid flow from UN agencies (US$) in 2009 and Aid flow from UN agencies (US$) in 2012 in Sub-Saharan Africa (all income levels)?
Your answer should be compact. 1.30e+07. What is the difference between the Aid flow from UN agencies (US$) of 2010 and Aid flow from UN agencies (US$) of 2011 in Sub-Saharan Africa (all income levels)?
Provide a short and direct response. -1.64e+07. What is the difference between the Aid flow from UN agencies (US$) of 2010 and Aid flow from UN agencies (US$) of 2012 in Sub-Saharan Africa (all income levels)?
Your answer should be compact. -8.10e+05. What is the difference between the Aid flow from UN agencies (US$) of 2011 and Aid flow from UN agencies (US$) of 2012 in Sub-Saharan Africa (all income levels)?
Make the answer very short. 1.56e+07. What is the difference between the Aid flow from UN agencies (US$) of 2009 and Aid flow from UN agencies (US$) of 2010 in Sub-Saharan Africa (developing only)?
Make the answer very short. 1.39e+07. What is the difference between the Aid flow from UN agencies (US$) of 2009 and Aid flow from UN agencies (US$) of 2011 in Sub-Saharan Africa (developing only)?
Give a very brief answer. -1.86e+06. What is the difference between the Aid flow from UN agencies (US$) of 2009 and Aid flow from UN agencies (US$) of 2012 in Sub-Saharan Africa (developing only)?
Make the answer very short. 1.38e+07. What is the difference between the Aid flow from UN agencies (US$) of 2010 and Aid flow from UN agencies (US$) of 2011 in Sub-Saharan Africa (developing only)?
Offer a very short reply. -1.57e+07. What is the difference between the Aid flow from UN agencies (US$) of 2011 and Aid flow from UN agencies (US$) of 2012 in Sub-Saharan Africa (developing only)?
Make the answer very short. 1.56e+07. What is the ratio of the Aid flow from UN agencies (US$) of 2009 in Latin America(all income levels) to that in Low & middle income?
Your answer should be compact. 0.1. What is the ratio of the Aid flow from UN agencies (US$) in 2010 in Latin America(all income levels) to that in Low & middle income?
Your response must be concise. 0.1. What is the ratio of the Aid flow from UN agencies (US$) of 2011 in Latin America(all income levels) to that in Low & middle income?
Ensure brevity in your answer.  0.09. What is the ratio of the Aid flow from UN agencies (US$) in 2012 in Latin America(all income levels) to that in Low & middle income?
Your response must be concise. 0.09. What is the ratio of the Aid flow from UN agencies (US$) in 2009 in Latin America(all income levels) to that in Middle income?
Offer a terse response. 2. What is the ratio of the Aid flow from UN agencies (US$) in 2010 in Latin America(all income levels) to that in Middle income?
Keep it short and to the point. 1.5. What is the ratio of the Aid flow from UN agencies (US$) in 2011 in Latin America(all income levels) to that in Middle income?
Make the answer very short. 0.43. What is the ratio of the Aid flow from UN agencies (US$) in 2012 in Latin America(all income levels) to that in Middle income?
Give a very brief answer. 0.45. What is the ratio of the Aid flow from UN agencies (US$) in 2009 in Latin America(all income levels) to that in Sub-Saharan Africa (all income levels)?
Your response must be concise. 0.4. What is the ratio of the Aid flow from UN agencies (US$) of 2010 in Latin America(all income levels) to that in Sub-Saharan Africa (all income levels)?
Keep it short and to the point. 0.42. What is the ratio of the Aid flow from UN agencies (US$) in 2011 in Latin America(all income levels) to that in Sub-Saharan Africa (all income levels)?
Ensure brevity in your answer.  0.37. What is the ratio of the Aid flow from UN agencies (US$) in 2012 in Latin America(all income levels) to that in Sub-Saharan Africa (all income levels)?
Offer a very short reply. 0.41. What is the ratio of the Aid flow from UN agencies (US$) of 2009 in Latin America(all income levels) to that in Sub-Saharan Africa (developing only)?
Ensure brevity in your answer.  0.4. What is the ratio of the Aid flow from UN agencies (US$) of 2010 in Latin America(all income levels) to that in Sub-Saharan Africa (developing only)?
Offer a very short reply. 0.42. What is the ratio of the Aid flow from UN agencies (US$) of 2011 in Latin America(all income levels) to that in Sub-Saharan Africa (developing only)?
Offer a terse response. 0.37. What is the ratio of the Aid flow from UN agencies (US$) of 2012 in Latin America(all income levels) to that in Sub-Saharan Africa (developing only)?
Offer a very short reply. 0.42. What is the ratio of the Aid flow from UN agencies (US$) in 2009 in Latin America(developing only) to that in Low & middle income?
Make the answer very short. 0.1. What is the ratio of the Aid flow from UN agencies (US$) of 2010 in Latin America(developing only) to that in Low & middle income?
Provide a succinct answer. 0.1. What is the ratio of the Aid flow from UN agencies (US$) of 2011 in Latin America(developing only) to that in Low & middle income?
Provide a succinct answer. 0.09. What is the ratio of the Aid flow from UN agencies (US$) in 2012 in Latin America(developing only) to that in Low & middle income?
Provide a succinct answer. 0.09. What is the ratio of the Aid flow from UN agencies (US$) in 2009 in Latin America(developing only) to that in Middle income?
Your answer should be very brief. 2. What is the ratio of the Aid flow from UN agencies (US$) in 2010 in Latin America(developing only) to that in Middle income?
Provide a short and direct response. 1.5. What is the ratio of the Aid flow from UN agencies (US$) of 2011 in Latin America(developing only) to that in Middle income?
Your answer should be very brief. 0.43. What is the ratio of the Aid flow from UN agencies (US$) in 2012 in Latin America(developing only) to that in Middle income?
Give a very brief answer. 0.45. What is the ratio of the Aid flow from UN agencies (US$) in 2009 in Latin America(developing only) to that in Sub-Saharan Africa (all income levels)?
Offer a very short reply. 0.4. What is the ratio of the Aid flow from UN agencies (US$) of 2010 in Latin America(developing only) to that in Sub-Saharan Africa (all income levels)?
Ensure brevity in your answer.  0.42. What is the ratio of the Aid flow from UN agencies (US$) of 2011 in Latin America(developing only) to that in Sub-Saharan Africa (all income levels)?
Make the answer very short. 0.37. What is the ratio of the Aid flow from UN agencies (US$) in 2012 in Latin America(developing only) to that in Sub-Saharan Africa (all income levels)?
Offer a terse response. 0.41. What is the ratio of the Aid flow from UN agencies (US$) of 2009 in Latin America(developing only) to that in Sub-Saharan Africa (developing only)?
Offer a terse response. 0.4. What is the ratio of the Aid flow from UN agencies (US$) in 2010 in Latin America(developing only) to that in Sub-Saharan Africa (developing only)?
Keep it short and to the point. 0.42. What is the ratio of the Aid flow from UN agencies (US$) of 2011 in Latin America(developing only) to that in Sub-Saharan Africa (developing only)?
Provide a succinct answer. 0.37. What is the ratio of the Aid flow from UN agencies (US$) of 2012 in Latin America(developing only) to that in Sub-Saharan Africa (developing only)?
Offer a very short reply. 0.42. What is the ratio of the Aid flow from UN agencies (US$) of 2009 in Low & middle income to that in Middle income?
Offer a terse response. 21. What is the ratio of the Aid flow from UN agencies (US$) in 2010 in Low & middle income to that in Middle income?
Provide a short and direct response. 14.61. What is the ratio of the Aid flow from UN agencies (US$) of 2011 in Low & middle income to that in Middle income?
Give a very brief answer. 5.02. What is the ratio of the Aid flow from UN agencies (US$) in 2012 in Low & middle income to that in Middle income?
Ensure brevity in your answer.  4.76. What is the ratio of the Aid flow from UN agencies (US$) of 2009 in Low & middle income to that in Sub-Saharan Africa (all income levels)?
Offer a terse response. 4.22. What is the ratio of the Aid flow from UN agencies (US$) of 2010 in Low & middle income to that in Sub-Saharan Africa (all income levels)?
Give a very brief answer. 4.08. What is the ratio of the Aid flow from UN agencies (US$) of 2011 in Low & middle income to that in Sub-Saharan Africa (all income levels)?
Provide a succinct answer. 4.25. What is the ratio of the Aid flow from UN agencies (US$) of 2012 in Low & middle income to that in Sub-Saharan Africa (all income levels)?
Give a very brief answer. 4.38. What is the ratio of the Aid flow from UN agencies (US$) of 2009 in Low & middle income to that in Sub-Saharan Africa (developing only)?
Ensure brevity in your answer.  4.22. What is the ratio of the Aid flow from UN agencies (US$) of 2010 in Low & middle income to that in Sub-Saharan Africa (developing only)?
Offer a very short reply. 4.08. What is the ratio of the Aid flow from UN agencies (US$) of 2011 in Low & middle income to that in Sub-Saharan Africa (developing only)?
Keep it short and to the point. 4.28. What is the ratio of the Aid flow from UN agencies (US$) of 2012 in Low & middle income to that in Sub-Saharan Africa (developing only)?
Your answer should be compact. 4.41. What is the ratio of the Aid flow from UN agencies (US$) of 2009 in Middle income to that in Sub-Saharan Africa (all income levels)?
Your answer should be compact. 0.2. What is the ratio of the Aid flow from UN agencies (US$) in 2010 in Middle income to that in Sub-Saharan Africa (all income levels)?
Your answer should be very brief. 0.28. What is the ratio of the Aid flow from UN agencies (US$) of 2011 in Middle income to that in Sub-Saharan Africa (all income levels)?
Offer a very short reply. 0.85. What is the ratio of the Aid flow from UN agencies (US$) of 2012 in Middle income to that in Sub-Saharan Africa (all income levels)?
Your answer should be compact. 0.92. What is the ratio of the Aid flow from UN agencies (US$) in 2009 in Middle income to that in Sub-Saharan Africa (developing only)?
Offer a very short reply. 0.2. What is the ratio of the Aid flow from UN agencies (US$) in 2010 in Middle income to that in Sub-Saharan Africa (developing only)?
Your response must be concise. 0.28. What is the ratio of the Aid flow from UN agencies (US$) in 2011 in Middle income to that in Sub-Saharan Africa (developing only)?
Keep it short and to the point. 0.85. What is the ratio of the Aid flow from UN agencies (US$) in 2012 in Middle income to that in Sub-Saharan Africa (developing only)?
Your answer should be very brief. 0.93. What is the ratio of the Aid flow from UN agencies (US$) in 2010 in Sub-Saharan Africa (all income levels) to that in Sub-Saharan Africa (developing only)?
Provide a short and direct response. 1. What is the ratio of the Aid flow from UN agencies (US$) in 2011 in Sub-Saharan Africa (all income levels) to that in Sub-Saharan Africa (developing only)?
Ensure brevity in your answer.  1.01. What is the ratio of the Aid flow from UN agencies (US$) of 2012 in Sub-Saharan Africa (all income levels) to that in Sub-Saharan Africa (developing only)?
Ensure brevity in your answer.  1.01. What is the difference between the highest and the second highest Aid flow from UN agencies (US$) of 2009?
Ensure brevity in your answer.  3.33e+08. What is the difference between the highest and the second highest Aid flow from UN agencies (US$) of 2010?
Give a very brief answer. 2.76e+08. What is the difference between the highest and the second highest Aid flow from UN agencies (US$) in 2011?
Your response must be concise. 3.45e+08. What is the difference between the highest and the second highest Aid flow from UN agencies (US$) in 2012?
Provide a short and direct response. 3.06e+08. What is the difference between the highest and the lowest Aid flow from UN agencies (US$) in 2009?
Provide a succinct answer. 4.16e+08. What is the difference between the highest and the lowest Aid flow from UN agencies (US$) in 2010?
Your response must be concise. 3.41e+08. What is the difference between the highest and the lowest Aid flow from UN agencies (US$) of 2011?
Your answer should be compact. 4.13e+08. What is the difference between the highest and the lowest Aid flow from UN agencies (US$) of 2012?
Ensure brevity in your answer.  3.59e+08. 